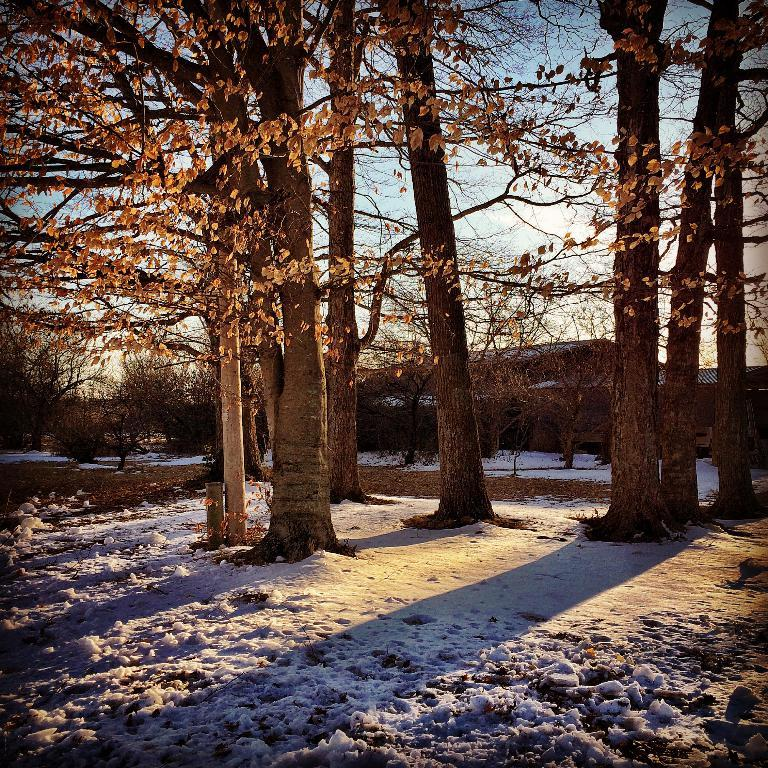What type of natural environment is depicted at the bottom of the image? There is snow at the bottom of the image. What can be seen in the background of the image? There are trees and houses in the background of the image. What is visible at the top of the image? The sky is visible at the top of the image. What type of plant is being taught in the class in the image? There is no class present in the image, so it is not possible to determine what type of plant might be taught. 